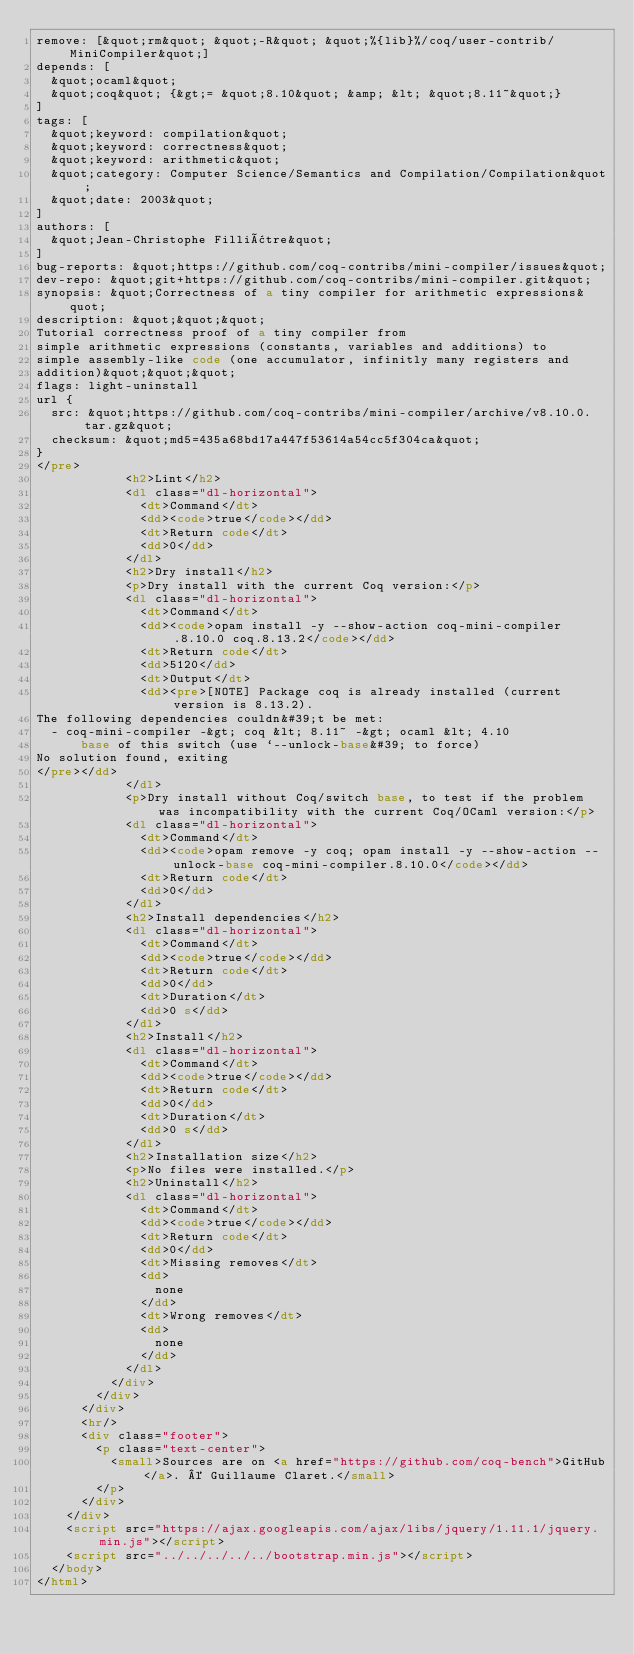Convert code to text. <code><loc_0><loc_0><loc_500><loc_500><_HTML_>remove: [&quot;rm&quot; &quot;-R&quot; &quot;%{lib}%/coq/user-contrib/MiniCompiler&quot;]
depends: [
  &quot;ocaml&quot;
  &quot;coq&quot; {&gt;= &quot;8.10&quot; &amp; &lt; &quot;8.11~&quot;}
]
tags: [
  &quot;keyword: compilation&quot;
  &quot;keyword: correctness&quot;
  &quot;keyword: arithmetic&quot;
  &quot;category: Computer Science/Semantics and Compilation/Compilation&quot;
  &quot;date: 2003&quot;
]
authors: [
  &quot;Jean-Christophe Filliâtre&quot;
]
bug-reports: &quot;https://github.com/coq-contribs/mini-compiler/issues&quot;
dev-repo: &quot;git+https://github.com/coq-contribs/mini-compiler.git&quot;
synopsis: &quot;Correctness of a tiny compiler for arithmetic expressions&quot;
description: &quot;&quot;&quot;
Tutorial correctness proof of a tiny compiler from
simple arithmetic expressions (constants, variables and additions) to
simple assembly-like code (one accumulator, infinitly many registers and
addition)&quot;&quot;&quot;
flags: light-uninstall
url {
  src: &quot;https://github.com/coq-contribs/mini-compiler/archive/v8.10.0.tar.gz&quot;
  checksum: &quot;md5=435a68bd17a447f53614a54cc5f304ca&quot;
}
</pre>
            <h2>Lint</h2>
            <dl class="dl-horizontal">
              <dt>Command</dt>
              <dd><code>true</code></dd>
              <dt>Return code</dt>
              <dd>0</dd>
            </dl>
            <h2>Dry install</h2>
            <p>Dry install with the current Coq version:</p>
            <dl class="dl-horizontal">
              <dt>Command</dt>
              <dd><code>opam install -y --show-action coq-mini-compiler.8.10.0 coq.8.13.2</code></dd>
              <dt>Return code</dt>
              <dd>5120</dd>
              <dt>Output</dt>
              <dd><pre>[NOTE] Package coq is already installed (current version is 8.13.2).
The following dependencies couldn&#39;t be met:
  - coq-mini-compiler -&gt; coq &lt; 8.11~ -&gt; ocaml &lt; 4.10
      base of this switch (use `--unlock-base&#39; to force)
No solution found, exiting
</pre></dd>
            </dl>
            <p>Dry install without Coq/switch base, to test if the problem was incompatibility with the current Coq/OCaml version:</p>
            <dl class="dl-horizontal">
              <dt>Command</dt>
              <dd><code>opam remove -y coq; opam install -y --show-action --unlock-base coq-mini-compiler.8.10.0</code></dd>
              <dt>Return code</dt>
              <dd>0</dd>
            </dl>
            <h2>Install dependencies</h2>
            <dl class="dl-horizontal">
              <dt>Command</dt>
              <dd><code>true</code></dd>
              <dt>Return code</dt>
              <dd>0</dd>
              <dt>Duration</dt>
              <dd>0 s</dd>
            </dl>
            <h2>Install</h2>
            <dl class="dl-horizontal">
              <dt>Command</dt>
              <dd><code>true</code></dd>
              <dt>Return code</dt>
              <dd>0</dd>
              <dt>Duration</dt>
              <dd>0 s</dd>
            </dl>
            <h2>Installation size</h2>
            <p>No files were installed.</p>
            <h2>Uninstall</h2>
            <dl class="dl-horizontal">
              <dt>Command</dt>
              <dd><code>true</code></dd>
              <dt>Return code</dt>
              <dd>0</dd>
              <dt>Missing removes</dt>
              <dd>
                none
              </dd>
              <dt>Wrong removes</dt>
              <dd>
                none
              </dd>
            </dl>
          </div>
        </div>
      </div>
      <hr/>
      <div class="footer">
        <p class="text-center">
          <small>Sources are on <a href="https://github.com/coq-bench">GitHub</a>. © Guillaume Claret.</small>
        </p>
      </div>
    </div>
    <script src="https://ajax.googleapis.com/ajax/libs/jquery/1.11.1/jquery.min.js"></script>
    <script src="../../../../../bootstrap.min.js"></script>
  </body>
</html>
</code> 